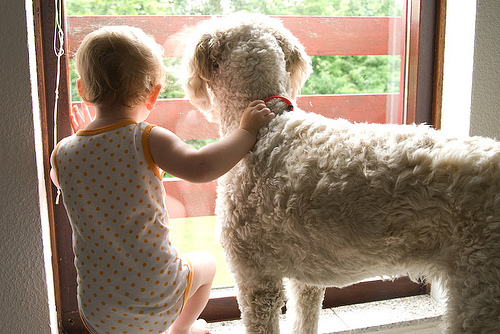<image>
Is there a kid under the dog? No. The kid is not positioned under the dog. The vertical relationship between these objects is different. 